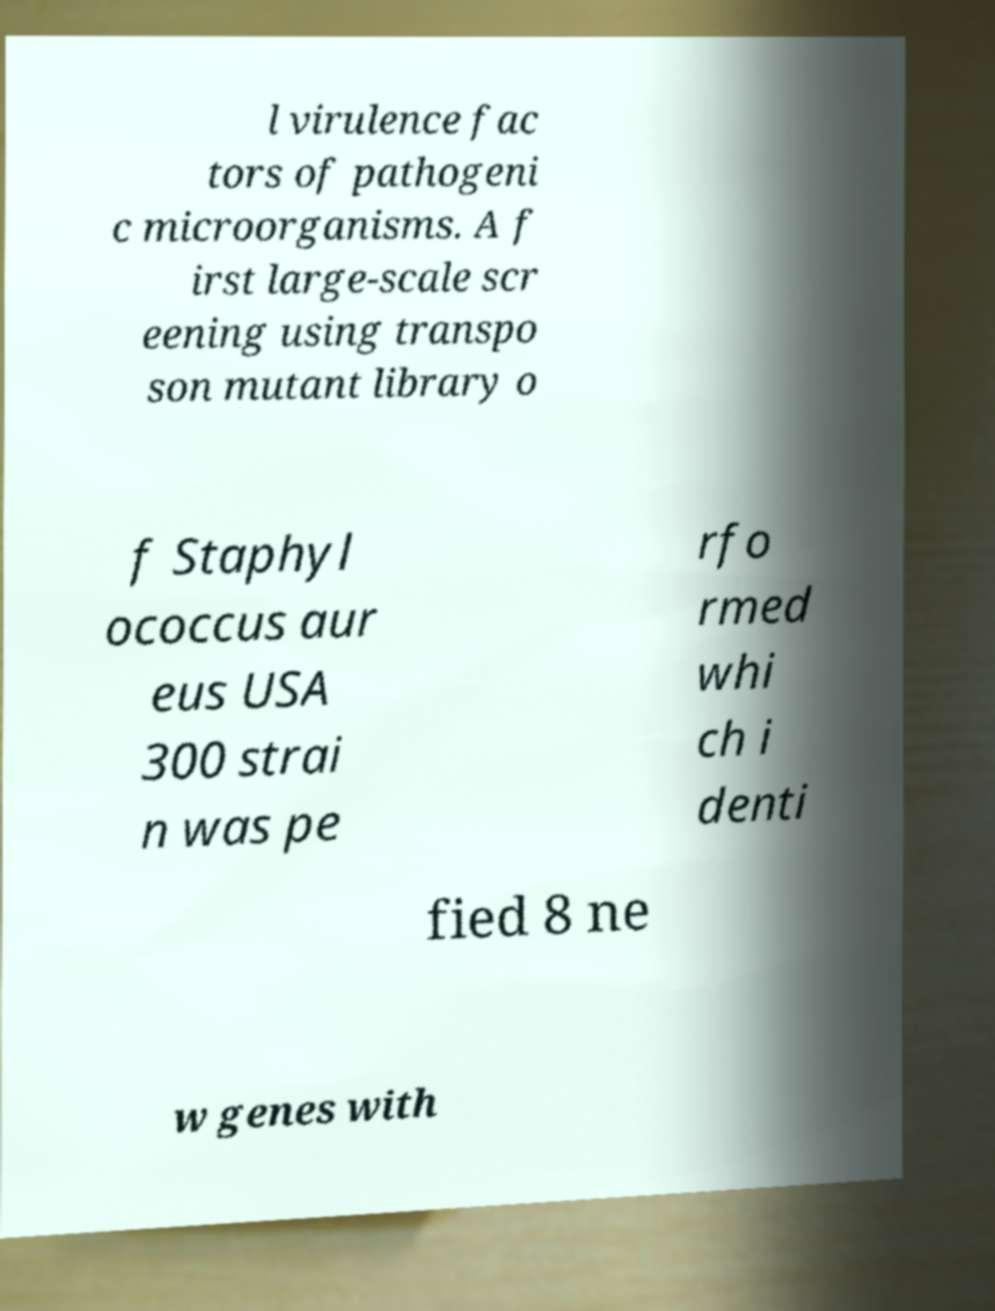What messages or text are displayed in this image? I need them in a readable, typed format. l virulence fac tors of pathogeni c microorganisms. A f irst large-scale scr eening using transpo son mutant library o f Staphyl ococcus aur eus USA 300 strai n was pe rfo rmed whi ch i denti fied 8 ne w genes with 